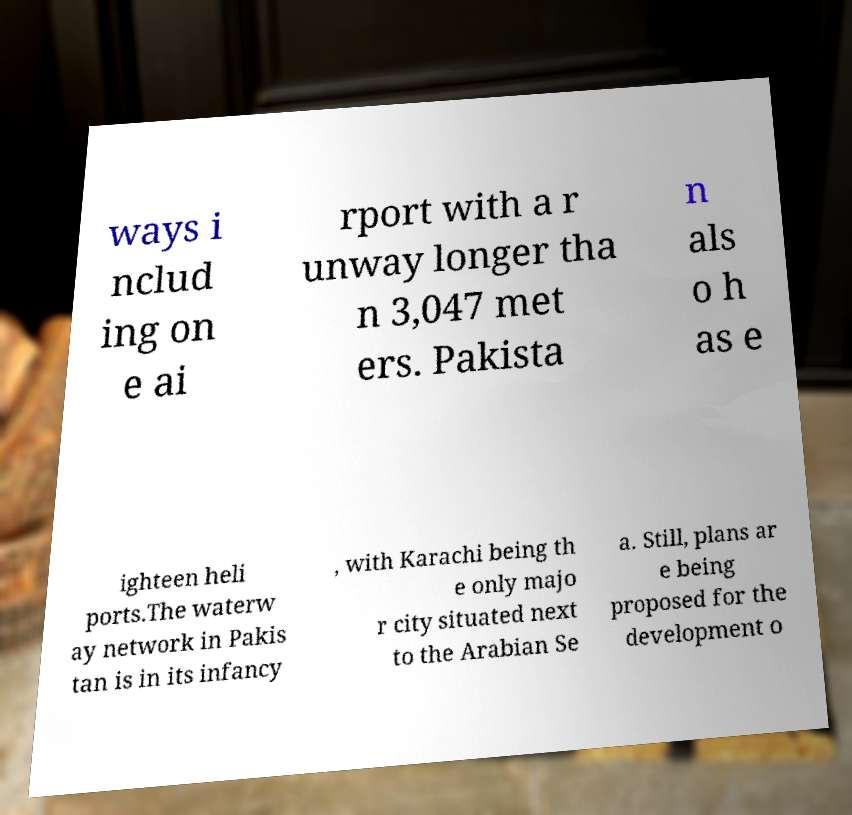There's text embedded in this image that I need extracted. Can you transcribe it verbatim? ways i nclud ing on e ai rport with a r unway longer tha n 3,047 met ers. Pakista n als o h as e ighteen heli ports.The waterw ay network in Pakis tan is in its infancy , with Karachi being th e only majo r city situated next to the Arabian Se a. Still, plans ar e being proposed for the development o 